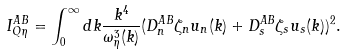Convert formula to latex. <formula><loc_0><loc_0><loc_500><loc_500>I ^ { A B } _ { Q \eta } = \int _ { 0 } ^ { \infty } d k \frac { k ^ { 4 } } { \omega _ { \eta } ^ { 3 } ( k ) } ( D ^ { A B } _ { n } \zeta _ { n } u _ { n } ( k ) + D ^ { A B } _ { s } \zeta _ { s } u _ { s } ( k ) ) ^ { 2 } .</formula> 